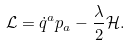<formula> <loc_0><loc_0><loc_500><loc_500>\mathcal { L } = \dot { q } ^ { a } p _ { a } - \frac { \lambda } { 2 } \mathcal { H } .</formula> 